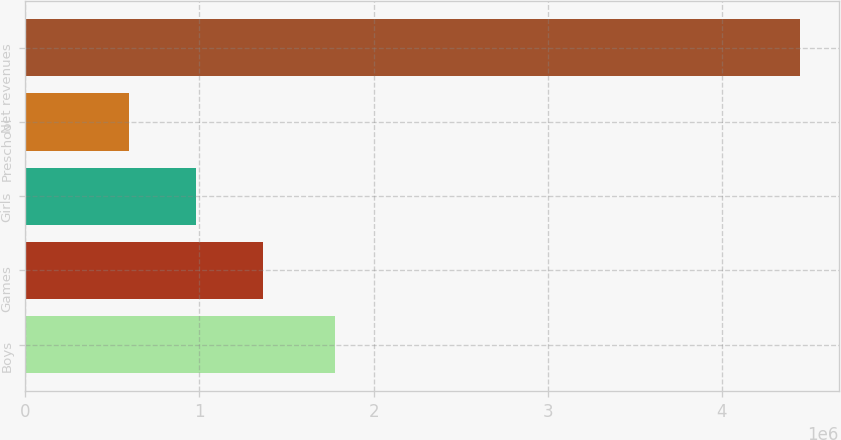Convert chart. <chart><loc_0><loc_0><loc_500><loc_500><bar_chart><fcel>Boys<fcel>Games<fcel>Girls<fcel>Preschool<fcel>Net revenues<nl><fcel>1.77592e+06<fcel>1.36696e+06<fcel>981889<fcel>596820<fcel>4.44751e+06<nl></chart> 